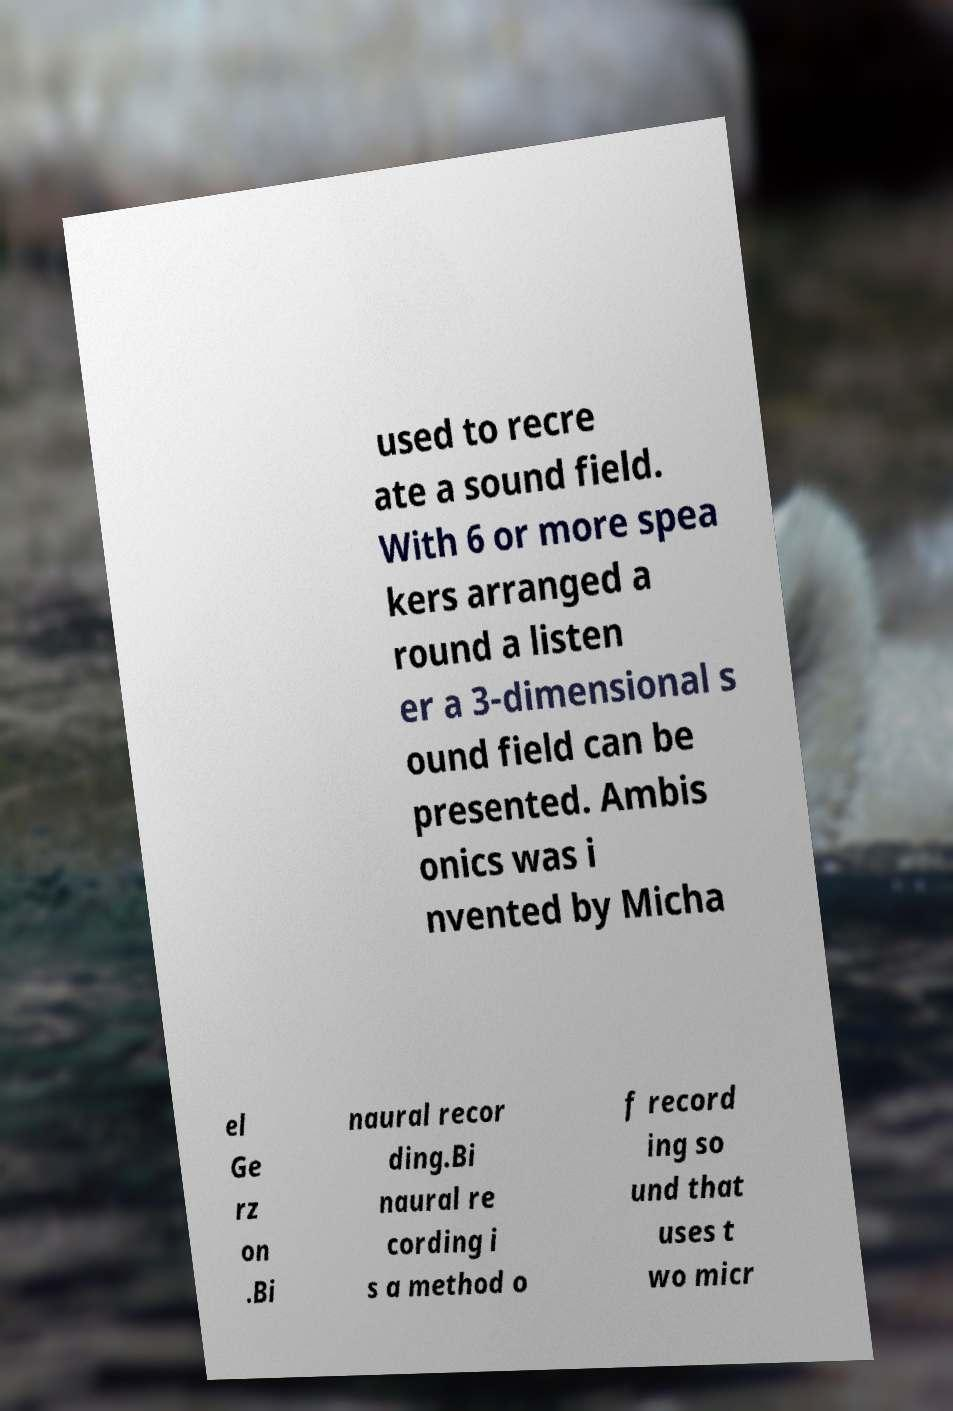Could you extract and type out the text from this image? used to recre ate a sound field. With 6 or more spea kers arranged a round a listen er a 3-dimensional s ound field can be presented. Ambis onics was i nvented by Micha el Ge rz on .Bi naural recor ding.Bi naural re cording i s a method o f record ing so und that uses t wo micr 